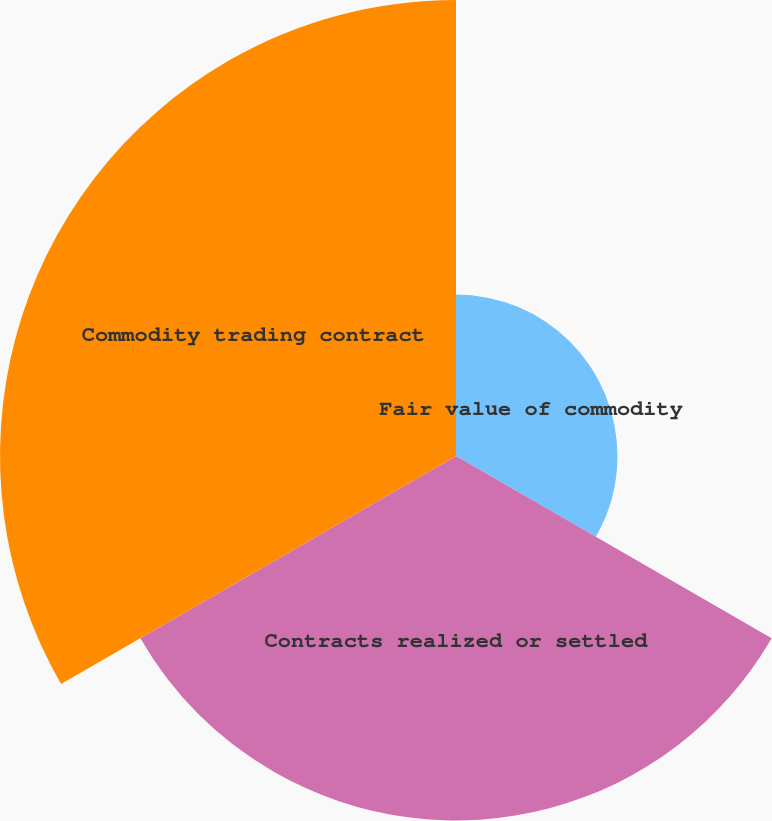<chart> <loc_0><loc_0><loc_500><loc_500><pie_chart><fcel>Fair value of commodity<fcel>Contracts realized or settled<fcel>Commodity trading contract<nl><fcel>16.44%<fcel>37.12%<fcel>46.44%<nl></chart> 